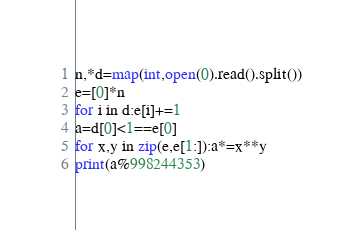<code> <loc_0><loc_0><loc_500><loc_500><_Python_>n,*d=map(int,open(0).read().split())
e=[0]*n
for i in d:e[i]+=1
a=d[0]<1==e[0]
for x,y in zip(e,e[1:]):a*=x**y
print(a%998244353)</code> 